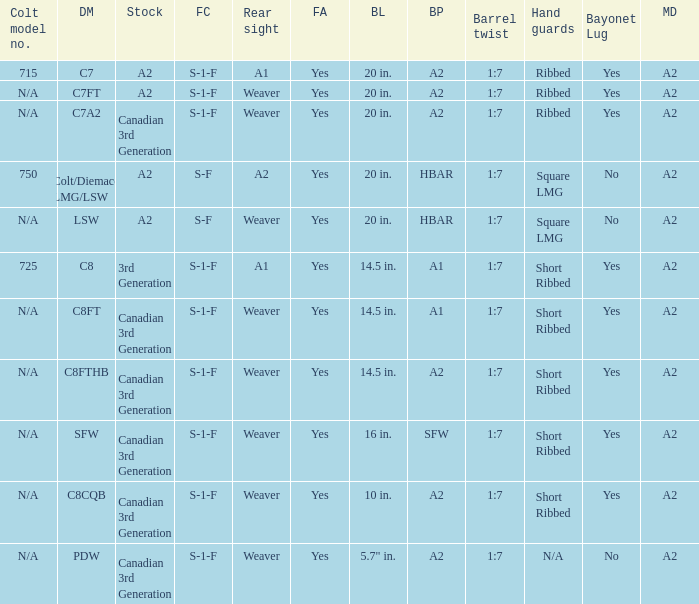Which Hand guards has a Barrel profile of a2 and a Rear sight of weaver? Ribbed, Ribbed, Short Ribbed, Short Ribbed, N/A. 